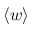Convert formula to latex. <formula><loc_0><loc_0><loc_500><loc_500>\langle w \rangle</formula> 